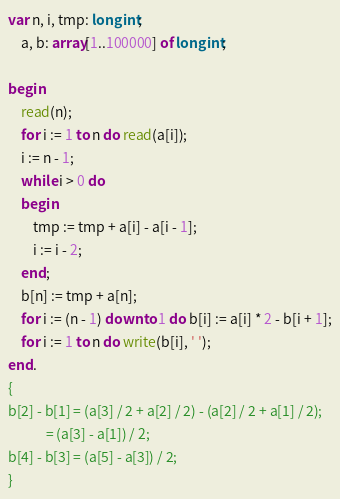<code> <loc_0><loc_0><loc_500><loc_500><_Pascal_>var n, i, tmp: longint;
    a, b: array[1..100000] of longint;

begin
    read(n);
    for i := 1 to n do read(a[i]);
    i := n - 1;
    while i > 0 do
    begin
        tmp := tmp + a[i] - a[i - 1];
        i := i - 2;
    end;
    b[n] := tmp + a[n];
    for i := (n - 1) downto 1 do b[i] := a[i] * 2 - b[i + 1];
    for i := 1 to n do write(b[i], ' ');
end.
{
b[2] - b[1] = (a[3] / 2 + a[2] / 2) - (a[2] / 2 + a[1] / 2);
            = (a[3] - a[1]) / 2;
b[4] - b[3] = (a[5] - a[3]) / 2;
}</code> 